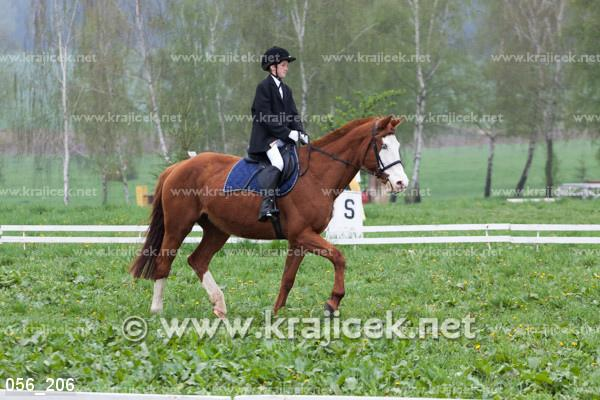What sport is this?

Choices:
A) volleyball
B) tennis
C) equestrian
D) baseball equestrian 